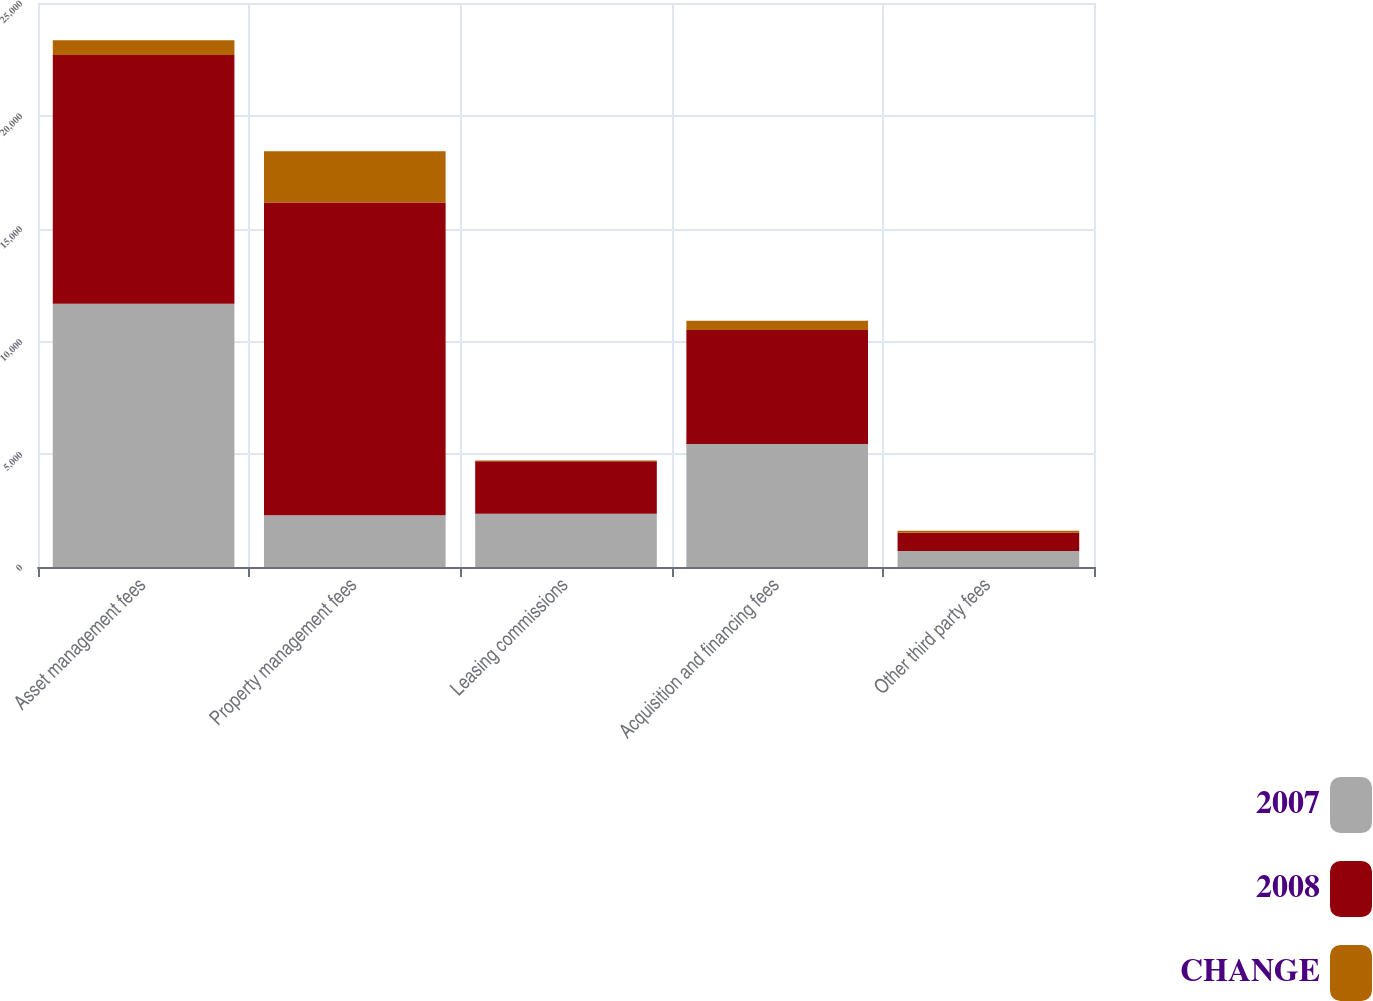<chart> <loc_0><loc_0><loc_500><loc_500><stacked_bar_chart><ecel><fcel>Asset management fees<fcel>Property management fees<fcel>Leasing commissions<fcel>Acquisition and financing fees<fcel>Other third party fees<nl><fcel>2007<fcel>11673<fcel>2293<fcel>2363<fcel>5455<fcel>709<nl><fcel>2008<fcel>11021<fcel>13865<fcel>2319<fcel>5055<fcel>804<nl><fcel>CHANGE<fcel>652<fcel>2267<fcel>44<fcel>400<fcel>95<nl></chart> 